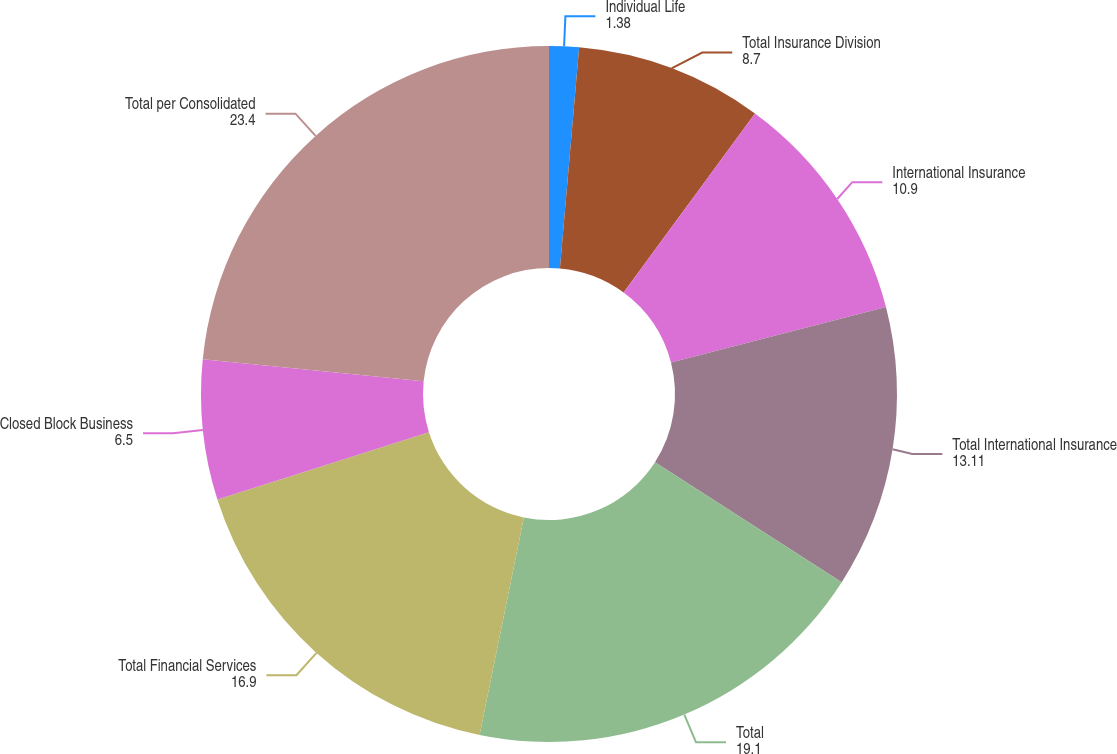Convert chart to OTSL. <chart><loc_0><loc_0><loc_500><loc_500><pie_chart><fcel>Individual Life<fcel>Total Insurance Division<fcel>International Insurance<fcel>Total International Insurance<fcel>Total<fcel>Total Financial Services<fcel>Closed Block Business<fcel>Total per Consolidated<nl><fcel>1.38%<fcel>8.7%<fcel>10.9%<fcel>13.11%<fcel>19.1%<fcel>16.9%<fcel>6.5%<fcel>23.4%<nl></chart> 